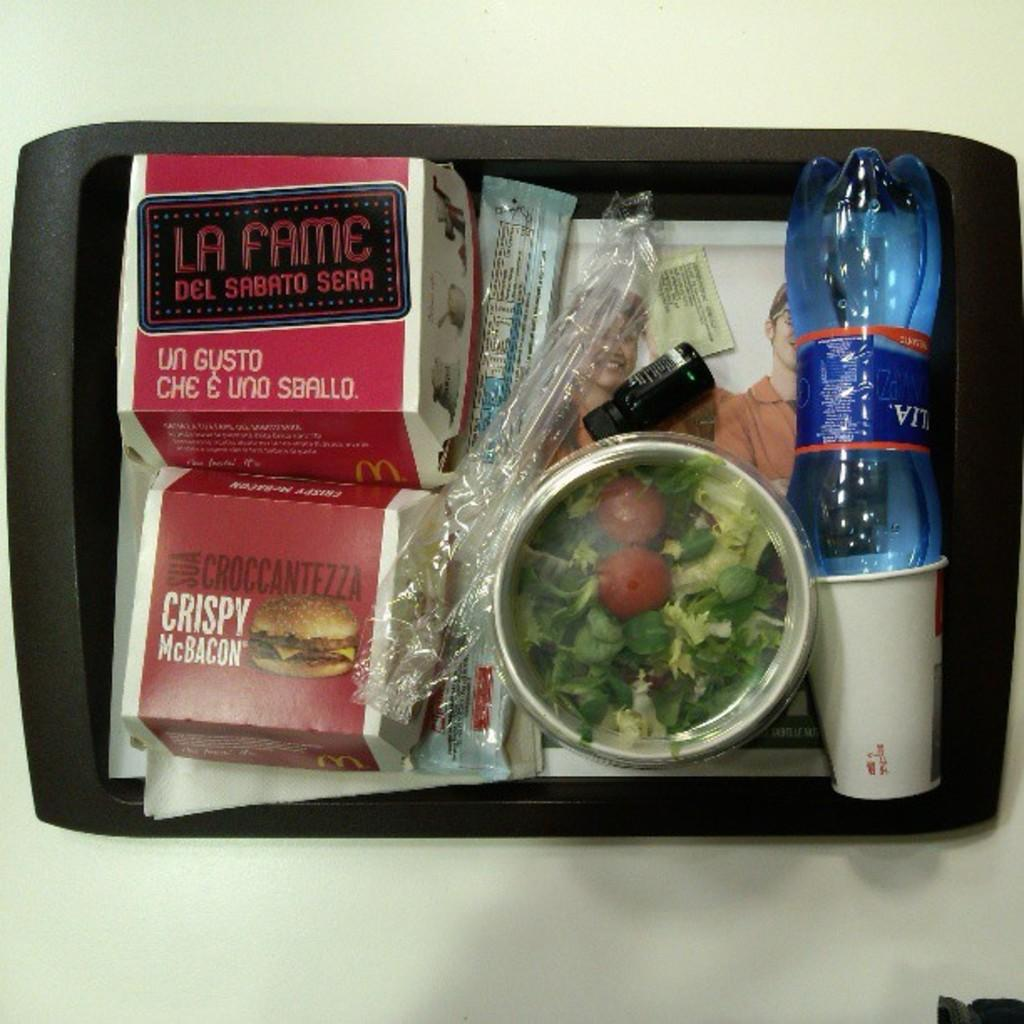<image>
Provide a brief description of the given image. Plate of mcdonalds food including a salad, burger, and water 